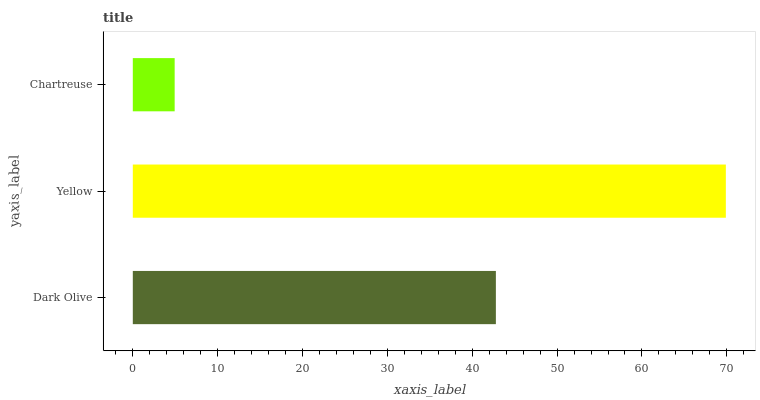Is Chartreuse the minimum?
Answer yes or no. Yes. Is Yellow the maximum?
Answer yes or no. Yes. Is Yellow the minimum?
Answer yes or no. No. Is Chartreuse the maximum?
Answer yes or no. No. Is Yellow greater than Chartreuse?
Answer yes or no. Yes. Is Chartreuse less than Yellow?
Answer yes or no. Yes. Is Chartreuse greater than Yellow?
Answer yes or no. No. Is Yellow less than Chartreuse?
Answer yes or no. No. Is Dark Olive the high median?
Answer yes or no. Yes. Is Dark Olive the low median?
Answer yes or no. Yes. Is Chartreuse the high median?
Answer yes or no. No. Is Chartreuse the low median?
Answer yes or no. No. 